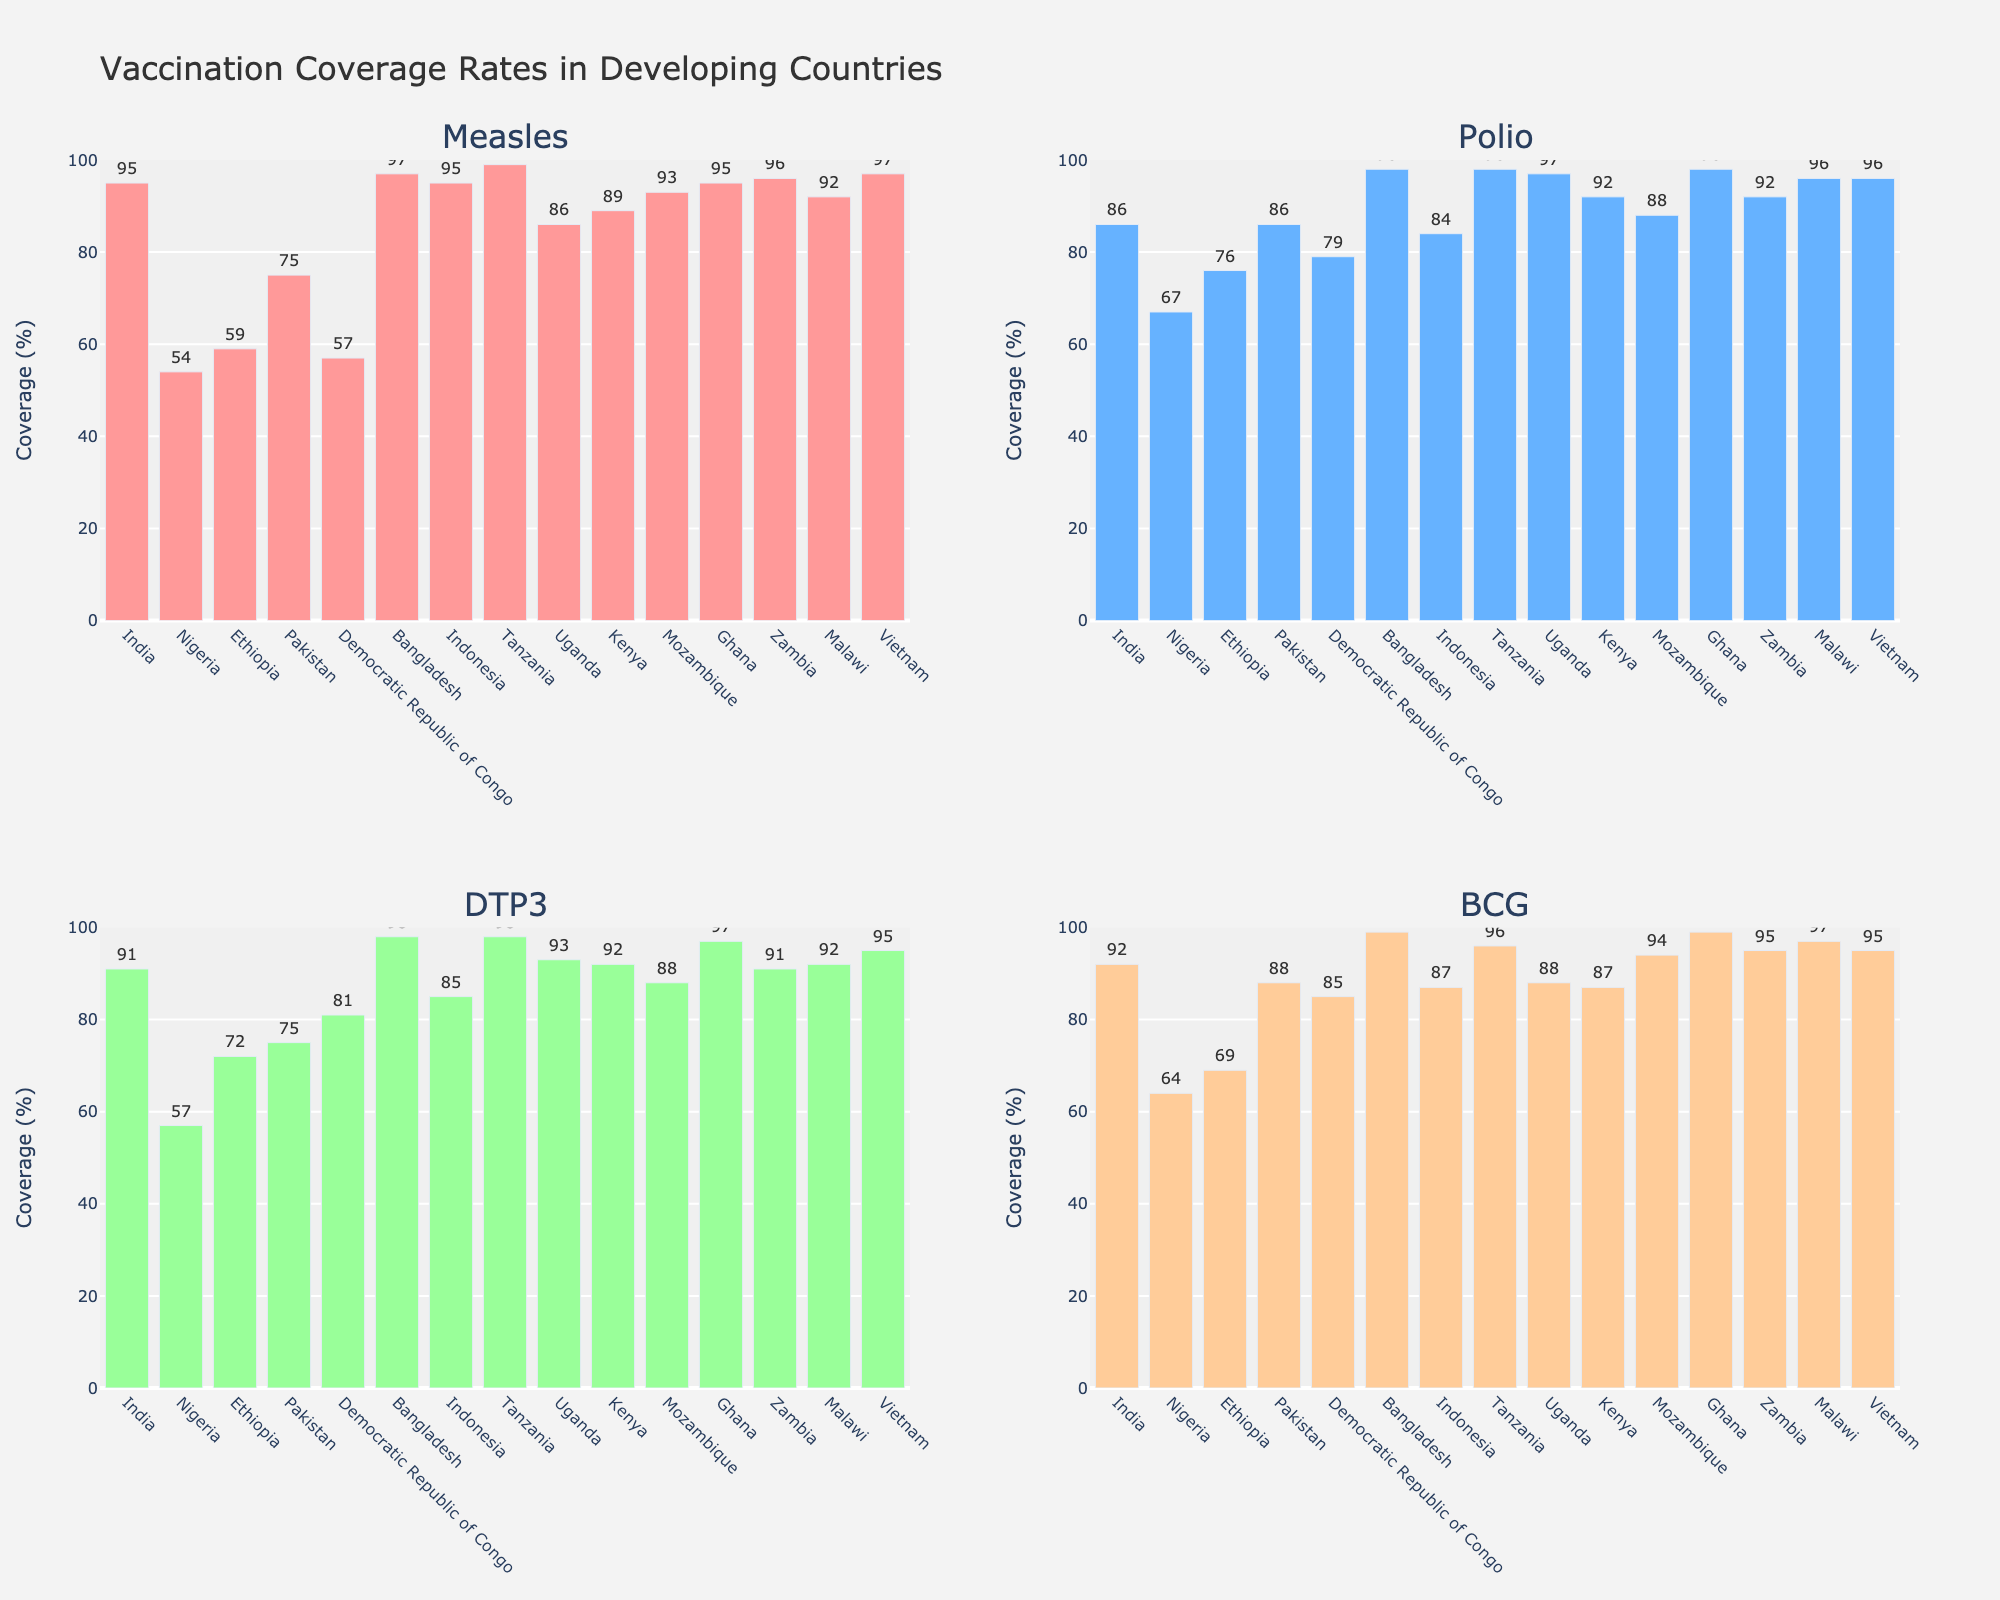Which country has the highest vaccination coverage for Measles? From the bar chart in the subplot for Measles, it can be seen visually that Tanzania has the highest bar indicating the highest coverage.
Answer: Tanzania Which preventable disease has the lowest coverage rate in Nigeria, and what is the percentage? By looking at the different subplots, Polio has a value of 67%, Measles 54%, DTP3 57%, and BCG 64%. The lowest of these is Measles at 54%.
Answer: Measles, 54% Compare the coverage of DTP3 and BCG in Kenya. Which one is higher and by how much? From the chart: DTP3 in Kenya is 92%, and BCG is 87%. The difference is 92% - 87% = 5%. Thus, DTP3 is higher by 5%.
Answer: DTP3, by 5% What is the average coverage rate for all four diseases in Uganda? The individual rates are Measles: 86%, Polio: 97%, DTP3: 93%, BCG: 88%. The average is calculated as (86 + 97 + 93 + 88) / 4 = 91%.
Answer: 91% Which country has the smallest range in vaccination coverage rates among the four diseases, and what is the range? Bangladesh has Measles: 97%, Polio: 98%, DTP3: 98%, and BCG: 99%. The range is 99% - 97% = 2%, which is smaller compared to other countries.
Answer: Bangladesh, 2% In the chart, which two countries have identical measles coverage rates? Both India and Indonesia have a measles coverage rate of 95%, as seen in the Measles subplot.
Answer: India and Indonesia What is the total vaccination coverage percentage for BCG across all countries depicted in the chart? Summing the BCG coverage percentages: 92 + 64 + 69 + 88 + 85 + 99 + 87 + 96 + 88 + 87 + 94 + 99 + 95 + 97 = 1200%.
Answer: 1200% For which disease does Vietnam have the highest coverage, and what is the percentage? From the chart, all four diseases (Measles, Polio, DTP3, BCG) have high values, with BCG and Measles both at 97%.
Answer: BCG, 97% 